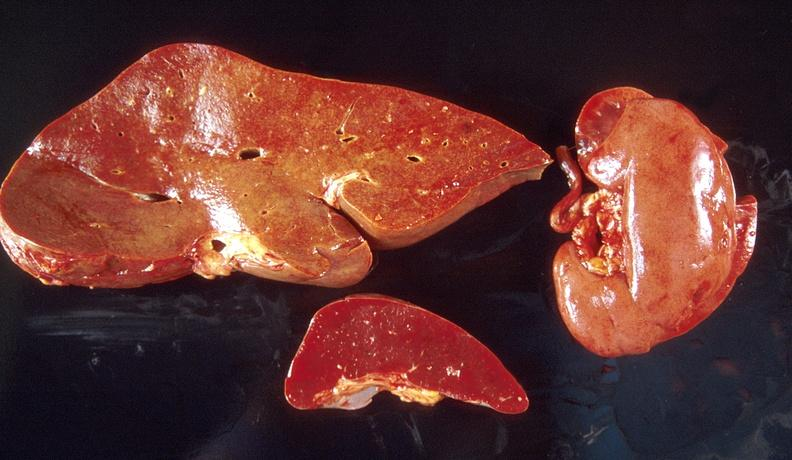s cranial artery present?
Answer the question using a single word or phrase. No 